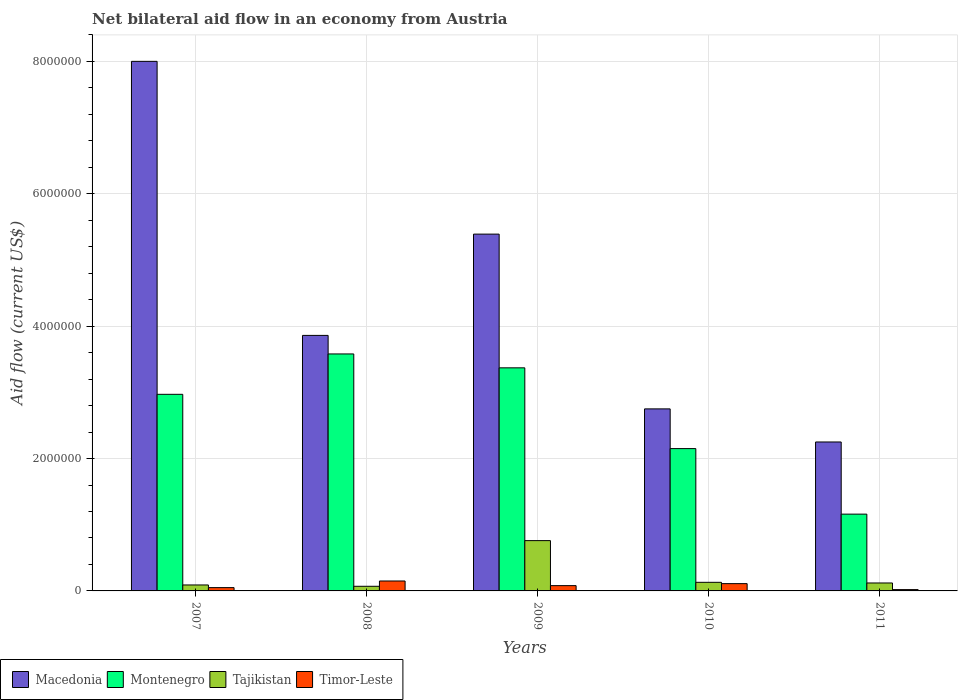Are the number of bars per tick equal to the number of legend labels?
Provide a short and direct response. Yes. Are the number of bars on each tick of the X-axis equal?
Your answer should be compact. Yes. How many bars are there on the 4th tick from the left?
Ensure brevity in your answer.  4. What is the label of the 2nd group of bars from the left?
Your response must be concise. 2008. Across all years, what is the minimum net bilateral aid flow in Tajikistan?
Make the answer very short. 7.00e+04. In which year was the net bilateral aid flow in Tajikistan maximum?
Make the answer very short. 2009. What is the difference between the net bilateral aid flow in Tajikistan in 2009 and that in 2010?
Provide a short and direct response. 6.30e+05. What is the difference between the net bilateral aid flow in Montenegro in 2008 and the net bilateral aid flow in Macedonia in 2011?
Give a very brief answer. 1.33e+06. What is the average net bilateral aid flow in Montenegro per year?
Make the answer very short. 2.65e+06. In the year 2011, what is the difference between the net bilateral aid flow in Macedonia and net bilateral aid flow in Tajikistan?
Your answer should be compact. 2.13e+06. In how many years, is the net bilateral aid flow in Timor-Leste greater than 3600000 US$?
Provide a succinct answer. 0. What is the ratio of the net bilateral aid flow in Montenegro in 2007 to that in 2009?
Offer a very short reply. 0.88. What is the difference between the highest and the lowest net bilateral aid flow in Montenegro?
Offer a terse response. 2.42e+06. Is the sum of the net bilateral aid flow in Macedonia in 2008 and 2011 greater than the maximum net bilateral aid flow in Montenegro across all years?
Offer a very short reply. Yes. What does the 2nd bar from the left in 2008 represents?
Your answer should be compact. Montenegro. What does the 1st bar from the right in 2008 represents?
Your answer should be very brief. Timor-Leste. Is it the case that in every year, the sum of the net bilateral aid flow in Macedonia and net bilateral aid flow in Timor-Leste is greater than the net bilateral aid flow in Tajikistan?
Offer a very short reply. Yes. How many bars are there?
Provide a short and direct response. 20. Are all the bars in the graph horizontal?
Ensure brevity in your answer.  No. How many years are there in the graph?
Give a very brief answer. 5. What is the difference between two consecutive major ticks on the Y-axis?
Your answer should be very brief. 2.00e+06. Does the graph contain any zero values?
Provide a succinct answer. No. How many legend labels are there?
Offer a very short reply. 4. What is the title of the graph?
Give a very brief answer. Net bilateral aid flow in an economy from Austria. What is the label or title of the X-axis?
Your response must be concise. Years. What is the label or title of the Y-axis?
Ensure brevity in your answer.  Aid flow (current US$). What is the Aid flow (current US$) of Macedonia in 2007?
Give a very brief answer. 8.00e+06. What is the Aid flow (current US$) of Montenegro in 2007?
Offer a terse response. 2.97e+06. What is the Aid flow (current US$) in Tajikistan in 2007?
Your response must be concise. 9.00e+04. What is the Aid flow (current US$) of Macedonia in 2008?
Offer a very short reply. 3.86e+06. What is the Aid flow (current US$) in Montenegro in 2008?
Make the answer very short. 3.58e+06. What is the Aid flow (current US$) of Tajikistan in 2008?
Your answer should be compact. 7.00e+04. What is the Aid flow (current US$) in Timor-Leste in 2008?
Provide a succinct answer. 1.50e+05. What is the Aid flow (current US$) in Macedonia in 2009?
Give a very brief answer. 5.39e+06. What is the Aid flow (current US$) of Montenegro in 2009?
Your answer should be very brief. 3.37e+06. What is the Aid flow (current US$) in Tajikistan in 2009?
Offer a very short reply. 7.60e+05. What is the Aid flow (current US$) of Timor-Leste in 2009?
Your answer should be compact. 8.00e+04. What is the Aid flow (current US$) of Macedonia in 2010?
Your answer should be compact. 2.75e+06. What is the Aid flow (current US$) in Montenegro in 2010?
Your answer should be compact. 2.15e+06. What is the Aid flow (current US$) of Tajikistan in 2010?
Offer a very short reply. 1.30e+05. What is the Aid flow (current US$) of Macedonia in 2011?
Provide a succinct answer. 2.25e+06. What is the Aid flow (current US$) of Montenegro in 2011?
Keep it short and to the point. 1.16e+06. Across all years, what is the maximum Aid flow (current US$) of Macedonia?
Your answer should be compact. 8.00e+06. Across all years, what is the maximum Aid flow (current US$) of Montenegro?
Your answer should be very brief. 3.58e+06. Across all years, what is the maximum Aid flow (current US$) in Tajikistan?
Give a very brief answer. 7.60e+05. Across all years, what is the maximum Aid flow (current US$) in Timor-Leste?
Your answer should be very brief. 1.50e+05. Across all years, what is the minimum Aid flow (current US$) of Macedonia?
Ensure brevity in your answer.  2.25e+06. Across all years, what is the minimum Aid flow (current US$) in Montenegro?
Provide a short and direct response. 1.16e+06. What is the total Aid flow (current US$) of Macedonia in the graph?
Keep it short and to the point. 2.22e+07. What is the total Aid flow (current US$) in Montenegro in the graph?
Your answer should be very brief. 1.32e+07. What is the total Aid flow (current US$) in Tajikistan in the graph?
Give a very brief answer. 1.17e+06. What is the difference between the Aid flow (current US$) in Macedonia in 2007 and that in 2008?
Your answer should be very brief. 4.14e+06. What is the difference between the Aid flow (current US$) of Montenegro in 2007 and that in 2008?
Make the answer very short. -6.10e+05. What is the difference between the Aid flow (current US$) of Macedonia in 2007 and that in 2009?
Offer a terse response. 2.61e+06. What is the difference between the Aid flow (current US$) in Montenegro in 2007 and that in 2009?
Offer a terse response. -4.00e+05. What is the difference between the Aid flow (current US$) in Tajikistan in 2007 and that in 2009?
Provide a short and direct response. -6.70e+05. What is the difference between the Aid flow (current US$) of Timor-Leste in 2007 and that in 2009?
Your answer should be very brief. -3.00e+04. What is the difference between the Aid flow (current US$) of Macedonia in 2007 and that in 2010?
Provide a short and direct response. 5.25e+06. What is the difference between the Aid flow (current US$) of Montenegro in 2007 and that in 2010?
Your response must be concise. 8.20e+05. What is the difference between the Aid flow (current US$) of Timor-Leste in 2007 and that in 2010?
Make the answer very short. -6.00e+04. What is the difference between the Aid flow (current US$) of Macedonia in 2007 and that in 2011?
Provide a short and direct response. 5.75e+06. What is the difference between the Aid flow (current US$) in Montenegro in 2007 and that in 2011?
Your answer should be very brief. 1.81e+06. What is the difference between the Aid flow (current US$) in Tajikistan in 2007 and that in 2011?
Provide a short and direct response. -3.00e+04. What is the difference between the Aid flow (current US$) in Timor-Leste in 2007 and that in 2011?
Your answer should be very brief. 3.00e+04. What is the difference between the Aid flow (current US$) of Macedonia in 2008 and that in 2009?
Give a very brief answer. -1.53e+06. What is the difference between the Aid flow (current US$) in Tajikistan in 2008 and that in 2009?
Give a very brief answer. -6.90e+05. What is the difference between the Aid flow (current US$) in Timor-Leste in 2008 and that in 2009?
Offer a terse response. 7.00e+04. What is the difference between the Aid flow (current US$) of Macedonia in 2008 and that in 2010?
Offer a terse response. 1.11e+06. What is the difference between the Aid flow (current US$) in Montenegro in 2008 and that in 2010?
Your response must be concise. 1.43e+06. What is the difference between the Aid flow (current US$) of Timor-Leste in 2008 and that in 2010?
Your answer should be very brief. 4.00e+04. What is the difference between the Aid flow (current US$) of Macedonia in 2008 and that in 2011?
Ensure brevity in your answer.  1.61e+06. What is the difference between the Aid flow (current US$) in Montenegro in 2008 and that in 2011?
Keep it short and to the point. 2.42e+06. What is the difference between the Aid flow (current US$) in Tajikistan in 2008 and that in 2011?
Ensure brevity in your answer.  -5.00e+04. What is the difference between the Aid flow (current US$) in Timor-Leste in 2008 and that in 2011?
Give a very brief answer. 1.30e+05. What is the difference between the Aid flow (current US$) in Macedonia in 2009 and that in 2010?
Your answer should be compact. 2.64e+06. What is the difference between the Aid flow (current US$) of Montenegro in 2009 and that in 2010?
Offer a terse response. 1.22e+06. What is the difference between the Aid flow (current US$) in Tajikistan in 2009 and that in 2010?
Your response must be concise. 6.30e+05. What is the difference between the Aid flow (current US$) in Timor-Leste in 2009 and that in 2010?
Ensure brevity in your answer.  -3.00e+04. What is the difference between the Aid flow (current US$) in Macedonia in 2009 and that in 2011?
Your answer should be very brief. 3.14e+06. What is the difference between the Aid flow (current US$) of Montenegro in 2009 and that in 2011?
Give a very brief answer. 2.21e+06. What is the difference between the Aid flow (current US$) in Tajikistan in 2009 and that in 2011?
Provide a succinct answer. 6.40e+05. What is the difference between the Aid flow (current US$) in Timor-Leste in 2009 and that in 2011?
Make the answer very short. 6.00e+04. What is the difference between the Aid flow (current US$) of Macedonia in 2010 and that in 2011?
Your answer should be very brief. 5.00e+05. What is the difference between the Aid flow (current US$) of Montenegro in 2010 and that in 2011?
Make the answer very short. 9.90e+05. What is the difference between the Aid flow (current US$) in Tajikistan in 2010 and that in 2011?
Your response must be concise. 10000. What is the difference between the Aid flow (current US$) in Macedonia in 2007 and the Aid flow (current US$) in Montenegro in 2008?
Make the answer very short. 4.42e+06. What is the difference between the Aid flow (current US$) in Macedonia in 2007 and the Aid flow (current US$) in Tajikistan in 2008?
Your answer should be very brief. 7.93e+06. What is the difference between the Aid flow (current US$) in Macedonia in 2007 and the Aid flow (current US$) in Timor-Leste in 2008?
Ensure brevity in your answer.  7.85e+06. What is the difference between the Aid flow (current US$) in Montenegro in 2007 and the Aid flow (current US$) in Tajikistan in 2008?
Your response must be concise. 2.90e+06. What is the difference between the Aid flow (current US$) in Montenegro in 2007 and the Aid flow (current US$) in Timor-Leste in 2008?
Give a very brief answer. 2.82e+06. What is the difference between the Aid flow (current US$) of Tajikistan in 2007 and the Aid flow (current US$) of Timor-Leste in 2008?
Your answer should be very brief. -6.00e+04. What is the difference between the Aid flow (current US$) in Macedonia in 2007 and the Aid flow (current US$) in Montenegro in 2009?
Offer a terse response. 4.63e+06. What is the difference between the Aid flow (current US$) of Macedonia in 2007 and the Aid flow (current US$) of Tajikistan in 2009?
Offer a very short reply. 7.24e+06. What is the difference between the Aid flow (current US$) in Macedonia in 2007 and the Aid flow (current US$) in Timor-Leste in 2009?
Your response must be concise. 7.92e+06. What is the difference between the Aid flow (current US$) of Montenegro in 2007 and the Aid flow (current US$) of Tajikistan in 2009?
Ensure brevity in your answer.  2.21e+06. What is the difference between the Aid flow (current US$) of Montenegro in 2007 and the Aid flow (current US$) of Timor-Leste in 2009?
Keep it short and to the point. 2.89e+06. What is the difference between the Aid flow (current US$) of Macedonia in 2007 and the Aid flow (current US$) of Montenegro in 2010?
Give a very brief answer. 5.85e+06. What is the difference between the Aid flow (current US$) of Macedonia in 2007 and the Aid flow (current US$) of Tajikistan in 2010?
Ensure brevity in your answer.  7.87e+06. What is the difference between the Aid flow (current US$) of Macedonia in 2007 and the Aid flow (current US$) of Timor-Leste in 2010?
Your answer should be very brief. 7.89e+06. What is the difference between the Aid flow (current US$) of Montenegro in 2007 and the Aid flow (current US$) of Tajikistan in 2010?
Provide a succinct answer. 2.84e+06. What is the difference between the Aid flow (current US$) of Montenegro in 2007 and the Aid flow (current US$) of Timor-Leste in 2010?
Keep it short and to the point. 2.86e+06. What is the difference between the Aid flow (current US$) of Tajikistan in 2007 and the Aid flow (current US$) of Timor-Leste in 2010?
Give a very brief answer. -2.00e+04. What is the difference between the Aid flow (current US$) of Macedonia in 2007 and the Aid flow (current US$) of Montenegro in 2011?
Offer a very short reply. 6.84e+06. What is the difference between the Aid flow (current US$) of Macedonia in 2007 and the Aid flow (current US$) of Tajikistan in 2011?
Ensure brevity in your answer.  7.88e+06. What is the difference between the Aid flow (current US$) in Macedonia in 2007 and the Aid flow (current US$) in Timor-Leste in 2011?
Give a very brief answer. 7.98e+06. What is the difference between the Aid flow (current US$) of Montenegro in 2007 and the Aid flow (current US$) of Tajikistan in 2011?
Ensure brevity in your answer.  2.85e+06. What is the difference between the Aid flow (current US$) in Montenegro in 2007 and the Aid flow (current US$) in Timor-Leste in 2011?
Provide a succinct answer. 2.95e+06. What is the difference between the Aid flow (current US$) in Tajikistan in 2007 and the Aid flow (current US$) in Timor-Leste in 2011?
Your response must be concise. 7.00e+04. What is the difference between the Aid flow (current US$) in Macedonia in 2008 and the Aid flow (current US$) in Tajikistan in 2009?
Your answer should be compact. 3.10e+06. What is the difference between the Aid flow (current US$) of Macedonia in 2008 and the Aid flow (current US$) of Timor-Leste in 2009?
Give a very brief answer. 3.78e+06. What is the difference between the Aid flow (current US$) in Montenegro in 2008 and the Aid flow (current US$) in Tajikistan in 2009?
Ensure brevity in your answer.  2.82e+06. What is the difference between the Aid flow (current US$) in Montenegro in 2008 and the Aid flow (current US$) in Timor-Leste in 2009?
Ensure brevity in your answer.  3.50e+06. What is the difference between the Aid flow (current US$) of Tajikistan in 2008 and the Aid flow (current US$) of Timor-Leste in 2009?
Offer a very short reply. -10000. What is the difference between the Aid flow (current US$) of Macedonia in 2008 and the Aid flow (current US$) of Montenegro in 2010?
Offer a terse response. 1.71e+06. What is the difference between the Aid flow (current US$) in Macedonia in 2008 and the Aid flow (current US$) in Tajikistan in 2010?
Offer a terse response. 3.73e+06. What is the difference between the Aid flow (current US$) of Macedonia in 2008 and the Aid flow (current US$) of Timor-Leste in 2010?
Your answer should be very brief. 3.75e+06. What is the difference between the Aid flow (current US$) of Montenegro in 2008 and the Aid flow (current US$) of Tajikistan in 2010?
Your answer should be very brief. 3.45e+06. What is the difference between the Aid flow (current US$) in Montenegro in 2008 and the Aid flow (current US$) in Timor-Leste in 2010?
Ensure brevity in your answer.  3.47e+06. What is the difference between the Aid flow (current US$) in Macedonia in 2008 and the Aid flow (current US$) in Montenegro in 2011?
Provide a succinct answer. 2.70e+06. What is the difference between the Aid flow (current US$) in Macedonia in 2008 and the Aid flow (current US$) in Tajikistan in 2011?
Provide a short and direct response. 3.74e+06. What is the difference between the Aid flow (current US$) in Macedonia in 2008 and the Aid flow (current US$) in Timor-Leste in 2011?
Your answer should be very brief. 3.84e+06. What is the difference between the Aid flow (current US$) of Montenegro in 2008 and the Aid flow (current US$) of Tajikistan in 2011?
Your answer should be compact. 3.46e+06. What is the difference between the Aid flow (current US$) in Montenegro in 2008 and the Aid flow (current US$) in Timor-Leste in 2011?
Offer a terse response. 3.56e+06. What is the difference between the Aid flow (current US$) of Tajikistan in 2008 and the Aid flow (current US$) of Timor-Leste in 2011?
Ensure brevity in your answer.  5.00e+04. What is the difference between the Aid flow (current US$) in Macedonia in 2009 and the Aid flow (current US$) in Montenegro in 2010?
Give a very brief answer. 3.24e+06. What is the difference between the Aid flow (current US$) in Macedonia in 2009 and the Aid flow (current US$) in Tajikistan in 2010?
Give a very brief answer. 5.26e+06. What is the difference between the Aid flow (current US$) in Macedonia in 2009 and the Aid flow (current US$) in Timor-Leste in 2010?
Make the answer very short. 5.28e+06. What is the difference between the Aid flow (current US$) in Montenegro in 2009 and the Aid flow (current US$) in Tajikistan in 2010?
Provide a short and direct response. 3.24e+06. What is the difference between the Aid flow (current US$) in Montenegro in 2009 and the Aid flow (current US$) in Timor-Leste in 2010?
Ensure brevity in your answer.  3.26e+06. What is the difference between the Aid flow (current US$) in Tajikistan in 2009 and the Aid flow (current US$) in Timor-Leste in 2010?
Offer a terse response. 6.50e+05. What is the difference between the Aid flow (current US$) of Macedonia in 2009 and the Aid flow (current US$) of Montenegro in 2011?
Give a very brief answer. 4.23e+06. What is the difference between the Aid flow (current US$) in Macedonia in 2009 and the Aid flow (current US$) in Tajikistan in 2011?
Keep it short and to the point. 5.27e+06. What is the difference between the Aid flow (current US$) of Macedonia in 2009 and the Aid flow (current US$) of Timor-Leste in 2011?
Keep it short and to the point. 5.37e+06. What is the difference between the Aid flow (current US$) of Montenegro in 2009 and the Aid flow (current US$) of Tajikistan in 2011?
Keep it short and to the point. 3.25e+06. What is the difference between the Aid flow (current US$) in Montenegro in 2009 and the Aid flow (current US$) in Timor-Leste in 2011?
Your response must be concise. 3.35e+06. What is the difference between the Aid flow (current US$) of Tajikistan in 2009 and the Aid flow (current US$) of Timor-Leste in 2011?
Make the answer very short. 7.40e+05. What is the difference between the Aid flow (current US$) of Macedonia in 2010 and the Aid flow (current US$) of Montenegro in 2011?
Your response must be concise. 1.59e+06. What is the difference between the Aid flow (current US$) in Macedonia in 2010 and the Aid flow (current US$) in Tajikistan in 2011?
Your answer should be very brief. 2.63e+06. What is the difference between the Aid flow (current US$) in Macedonia in 2010 and the Aid flow (current US$) in Timor-Leste in 2011?
Your answer should be compact. 2.73e+06. What is the difference between the Aid flow (current US$) in Montenegro in 2010 and the Aid flow (current US$) in Tajikistan in 2011?
Your answer should be compact. 2.03e+06. What is the difference between the Aid flow (current US$) in Montenegro in 2010 and the Aid flow (current US$) in Timor-Leste in 2011?
Offer a very short reply. 2.13e+06. What is the average Aid flow (current US$) of Macedonia per year?
Keep it short and to the point. 4.45e+06. What is the average Aid flow (current US$) in Montenegro per year?
Your answer should be compact. 2.65e+06. What is the average Aid flow (current US$) of Tajikistan per year?
Ensure brevity in your answer.  2.34e+05. What is the average Aid flow (current US$) of Timor-Leste per year?
Offer a terse response. 8.20e+04. In the year 2007, what is the difference between the Aid flow (current US$) in Macedonia and Aid flow (current US$) in Montenegro?
Your response must be concise. 5.03e+06. In the year 2007, what is the difference between the Aid flow (current US$) of Macedonia and Aid flow (current US$) of Tajikistan?
Offer a terse response. 7.91e+06. In the year 2007, what is the difference between the Aid flow (current US$) of Macedonia and Aid flow (current US$) of Timor-Leste?
Your answer should be very brief. 7.95e+06. In the year 2007, what is the difference between the Aid flow (current US$) of Montenegro and Aid flow (current US$) of Tajikistan?
Give a very brief answer. 2.88e+06. In the year 2007, what is the difference between the Aid flow (current US$) in Montenegro and Aid flow (current US$) in Timor-Leste?
Provide a succinct answer. 2.92e+06. In the year 2008, what is the difference between the Aid flow (current US$) in Macedonia and Aid flow (current US$) in Tajikistan?
Offer a terse response. 3.79e+06. In the year 2008, what is the difference between the Aid flow (current US$) in Macedonia and Aid flow (current US$) in Timor-Leste?
Your answer should be very brief. 3.71e+06. In the year 2008, what is the difference between the Aid flow (current US$) in Montenegro and Aid flow (current US$) in Tajikistan?
Offer a very short reply. 3.51e+06. In the year 2008, what is the difference between the Aid flow (current US$) of Montenegro and Aid flow (current US$) of Timor-Leste?
Your answer should be compact. 3.43e+06. In the year 2009, what is the difference between the Aid flow (current US$) in Macedonia and Aid flow (current US$) in Montenegro?
Make the answer very short. 2.02e+06. In the year 2009, what is the difference between the Aid flow (current US$) in Macedonia and Aid flow (current US$) in Tajikistan?
Give a very brief answer. 4.63e+06. In the year 2009, what is the difference between the Aid flow (current US$) in Macedonia and Aid flow (current US$) in Timor-Leste?
Provide a short and direct response. 5.31e+06. In the year 2009, what is the difference between the Aid flow (current US$) in Montenegro and Aid flow (current US$) in Tajikistan?
Your answer should be compact. 2.61e+06. In the year 2009, what is the difference between the Aid flow (current US$) in Montenegro and Aid flow (current US$) in Timor-Leste?
Offer a very short reply. 3.29e+06. In the year 2009, what is the difference between the Aid flow (current US$) in Tajikistan and Aid flow (current US$) in Timor-Leste?
Your answer should be very brief. 6.80e+05. In the year 2010, what is the difference between the Aid flow (current US$) of Macedonia and Aid flow (current US$) of Montenegro?
Your answer should be compact. 6.00e+05. In the year 2010, what is the difference between the Aid flow (current US$) in Macedonia and Aid flow (current US$) in Tajikistan?
Offer a terse response. 2.62e+06. In the year 2010, what is the difference between the Aid flow (current US$) in Macedonia and Aid flow (current US$) in Timor-Leste?
Your answer should be compact. 2.64e+06. In the year 2010, what is the difference between the Aid flow (current US$) in Montenegro and Aid flow (current US$) in Tajikistan?
Ensure brevity in your answer.  2.02e+06. In the year 2010, what is the difference between the Aid flow (current US$) in Montenegro and Aid flow (current US$) in Timor-Leste?
Provide a short and direct response. 2.04e+06. In the year 2010, what is the difference between the Aid flow (current US$) of Tajikistan and Aid flow (current US$) of Timor-Leste?
Your answer should be very brief. 2.00e+04. In the year 2011, what is the difference between the Aid flow (current US$) in Macedonia and Aid flow (current US$) in Montenegro?
Make the answer very short. 1.09e+06. In the year 2011, what is the difference between the Aid flow (current US$) of Macedonia and Aid flow (current US$) of Tajikistan?
Offer a terse response. 2.13e+06. In the year 2011, what is the difference between the Aid flow (current US$) in Macedonia and Aid flow (current US$) in Timor-Leste?
Keep it short and to the point. 2.23e+06. In the year 2011, what is the difference between the Aid flow (current US$) of Montenegro and Aid flow (current US$) of Tajikistan?
Your response must be concise. 1.04e+06. In the year 2011, what is the difference between the Aid flow (current US$) of Montenegro and Aid flow (current US$) of Timor-Leste?
Offer a terse response. 1.14e+06. What is the ratio of the Aid flow (current US$) of Macedonia in 2007 to that in 2008?
Provide a succinct answer. 2.07. What is the ratio of the Aid flow (current US$) in Montenegro in 2007 to that in 2008?
Your answer should be compact. 0.83. What is the ratio of the Aid flow (current US$) in Timor-Leste in 2007 to that in 2008?
Make the answer very short. 0.33. What is the ratio of the Aid flow (current US$) of Macedonia in 2007 to that in 2009?
Offer a terse response. 1.48. What is the ratio of the Aid flow (current US$) in Montenegro in 2007 to that in 2009?
Keep it short and to the point. 0.88. What is the ratio of the Aid flow (current US$) in Tajikistan in 2007 to that in 2009?
Make the answer very short. 0.12. What is the ratio of the Aid flow (current US$) of Timor-Leste in 2007 to that in 2009?
Offer a very short reply. 0.62. What is the ratio of the Aid flow (current US$) in Macedonia in 2007 to that in 2010?
Give a very brief answer. 2.91. What is the ratio of the Aid flow (current US$) of Montenegro in 2007 to that in 2010?
Give a very brief answer. 1.38. What is the ratio of the Aid flow (current US$) in Tajikistan in 2007 to that in 2010?
Your response must be concise. 0.69. What is the ratio of the Aid flow (current US$) of Timor-Leste in 2007 to that in 2010?
Offer a very short reply. 0.45. What is the ratio of the Aid flow (current US$) in Macedonia in 2007 to that in 2011?
Provide a short and direct response. 3.56. What is the ratio of the Aid flow (current US$) in Montenegro in 2007 to that in 2011?
Ensure brevity in your answer.  2.56. What is the ratio of the Aid flow (current US$) in Tajikistan in 2007 to that in 2011?
Keep it short and to the point. 0.75. What is the ratio of the Aid flow (current US$) in Timor-Leste in 2007 to that in 2011?
Provide a short and direct response. 2.5. What is the ratio of the Aid flow (current US$) in Macedonia in 2008 to that in 2009?
Your answer should be compact. 0.72. What is the ratio of the Aid flow (current US$) in Montenegro in 2008 to that in 2009?
Offer a very short reply. 1.06. What is the ratio of the Aid flow (current US$) of Tajikistan in 2008 to that in 2009?
Keep it short and to the point. 0.09. What is the ratio of the Aid flow (current US$) of Timor-Leste in 2008 to that in 2009?
Ensure brevity in your answer.  1.88. What is the ratio of the Aid flow (current US$) in Macedonia in 2008 to that in 2010?
Your answer should be compact. 1.4. What is the ratio of the Aid flow (current US$) of Montenegro in 2008 to that in 2010?
Ensure brevity in your answer.  1.67. What is the ratio of the Aid flow (current US$) in Tajikistan in 2008 to that in 2010?
Your response must be concise. 0.54. What is the ratio of the Aid flow (current US$) in Timor-Leste in 2008 to that in 2010?
Offer a terse response. 1.36. What is the ratio of the Aid flow (current US$) in Macedonia in 2008 to that in 2011?
Your response must be concise. 1.72. What is the ratio of the Aid flow (current US$) in Montenegro in 2008 to that in 2011?
Provide a short and direct response. 3.09. What is the ratio of the Aid flow (current US$) in Tajikistan in 2008 to that in 2011?
Your response must be concise. 0.58. What is the ratio of the Aid flow (current US$) of Timor-Leste in 2008 to that in 2011?
Ensure brevity in your answer.  7.5. What is the ratio of the Aid flow (current US$) of Macedonia in 2009 to that in 2010?
Ensure brevity in your answer.  1.96. What is the ratio of the Aid flow (current US$) in Montenegro in 2009 to that in 2010?
Make the answer very short. 1.57. What is the ratio of the Aid flow (current US$) in Tajikistan in 2009 to that in 2010?
Provide a succinct answer. 5.85. What is the ratio of the Aid flow (current US$) of Timor-Leste in 2009 to that in 2010?
Give a very brief answer. 0.73. What is the ratio of the Aid flow (current US$) of Macedonia in 2009 to that in 2011?
Your answer should be very brief. 2.4. What is the ratio of the Aid flow (current US$) of Montenegro in 2009 to that in 2011?
Your answer should be very brief. 2.91. What is the ratio of the Aid flow (current US$) in Tajikistan in 2009 to that in 2011?
Provide a short and direct response. 6.33. What is the ratio of the Aid flow (current US$) in Macedonia in 2010 to that in 2011?
Your answer should be compact. 1.22. What is the ratio of the Aid flow (current US$) of Montenegro in 2010 to that in 2011?
Provide a short and direct response. 1.85. What is the ratio of the Aid flow (current US$) of Tajikistan in 2010 to that in 2011?
Offer a terse response. 1.08. What is the difference between the highest and the second highest Aid flow (current US$) in Macedonia?
Ensure brevity in your answer.  2.61e+06. What is the difference between the highest and the second highest Aid flow (current US$) of Montenegro?
Ensure brevity in your answer.  2.10e+05. What is the difference between the highest and the second highest Aid flow (current US$) in Tajikistan?
Offer a very short reply. 6.30e+05. What is the difference between the highest and the second highest Aid flow (current US$) in Timor-Leste?
Offer a terse response. 4.00e+04. What is the difference between the highest and the lowest Aid flow (current US$) in Macedonia?
Offer a very short reply. 5.75e+06. What is the difference between the highest and the lowest Aid flow (current US$) of Montenegro?
Provide a succinct answer. 2.42e+06. What is the difference between the highest and the lowest Aid flow (current US$) of Tajikistan?
Your response must be concise. 6.90e+05. 